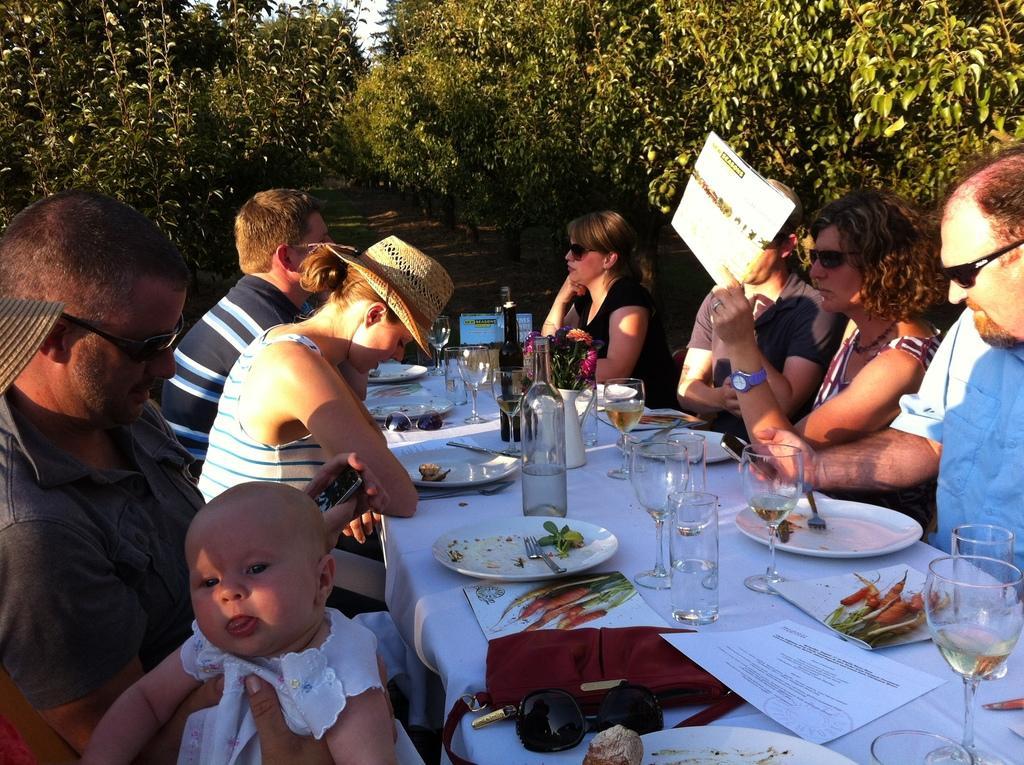Can you describe this image briefly? These are trees. These persons are sitting on chairs. On this table there are bottles, glasses, papers and plates. This woman is holding a card. 